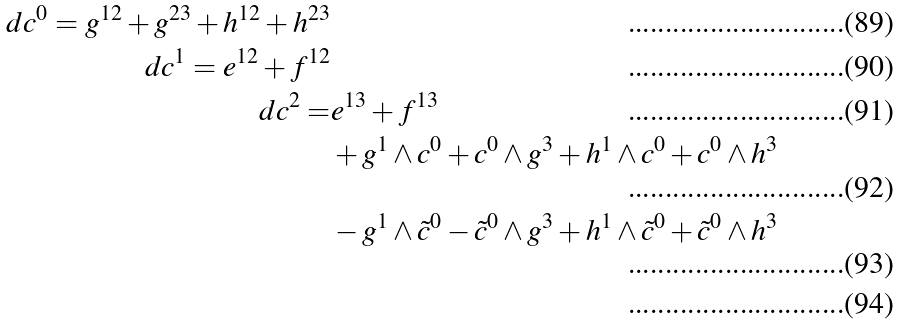Convert formula to latex. <formula><loc_0><loc_0><loc_500><loc_500>d c ^ { 0 } = g ^ { 1 2 } + g ^ { 2 3 } + h ^ { 1 2 } + h ^ { 2 3 } \\ d c ^ { 1 } = e ^ { 1 2 } + f ^ { 1 2 } \\ d c ^ { 2 } = & e ^ { 1 3 } + f ^ { 1 3 } \\ & + g ^ { 1 } \wedge c ^ { 0 } + c ^ { 0 } \wedge g ^ { 3 } + h ^ { 1 } \wedge c ^ { 0 } + c ^ { 0 } \wedge h ^ { 3 } \\ & - g ^ { 1 } \wedge \tilde { c } ^ { 0 } - \tilde { c } ^ { 0 } \wedge g ^ { 3 } + h ^ { 1 } \wedge \tilde { c } ^ { 0 } + \tilde { c } ^ { 0 } \wedge h ^ { 3 } \\</formula> 